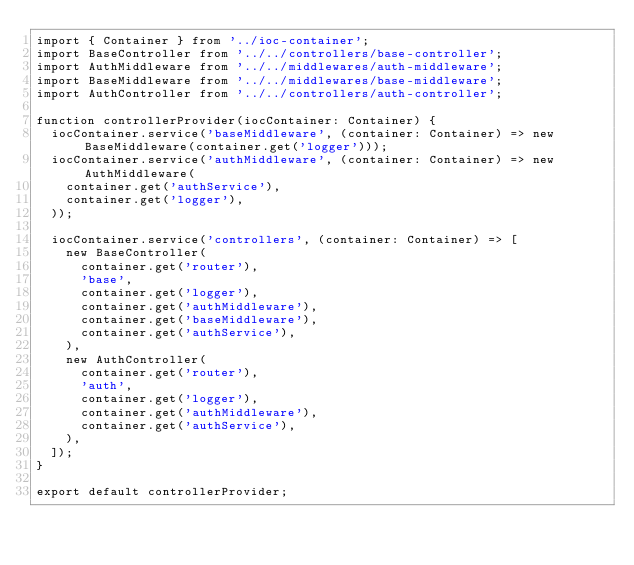Convert code to text. <code><loc_0><loc_0><loc_500><loc_500><_TypeScript_>import { Container } from '../ioc-container';
import BaseController from '../../controllers/base-controller';
import AuthMiddleware from '../../middlewares/auth-middleware';
import BaseMiddleware from '../../middlewares/base-middleware';
import AuthController from '../../controllers/auth-controller';

function controllerProvider(iocContainer: Container) {
  iocContainer.service('baseMiddleware', (container: Container) => new BaseMiddleware(container.get('logger')));
  iocContainer.service('authMiddleware', (container: Container) => new AuthMiddleware(
    container.get('authService'),
    container.get('logger'),
  ));

  iocContainer.service('controllers', (container: Container) => [
    new BaseController(
      container.get('router'),
      'base',
      container.get('logger'),
      container.get('authMiddleware'),
      container.get('baseMiddleware'),
      container.get('authService'),
    ),
    new AuthController(
      container.get('router'),
      'auth',
      container.get('logger'),
      container.get('authMiddleware'),
      container.get('authService'),
    ),
  ]);
}

export default controllerProvider;
</code> 